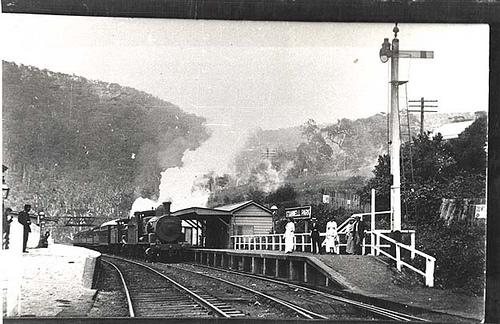What time of year is this?
Give a very brief answer. Winter. Is the train giving off steam?
Answer briefly. Yes. Is this a moving train?
Concise answer only. Yes. 